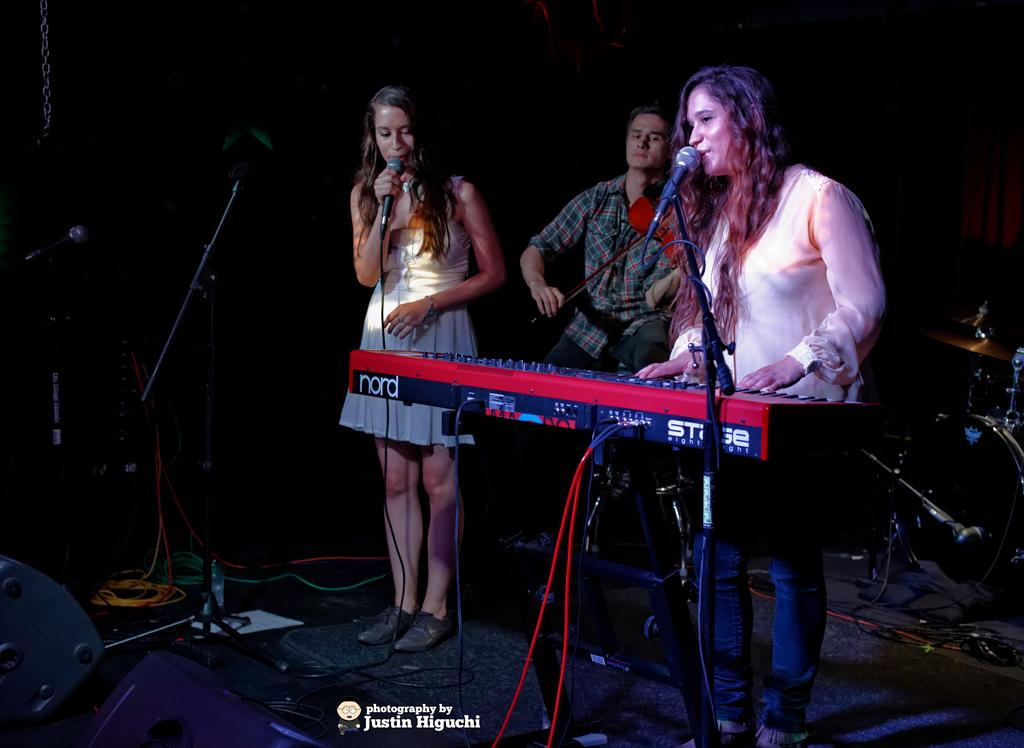How many people are present in the image? There are 3 people in the image. What are two of the people doing in the image? Two people are singing in the image. What is the third person doing in the image? One person is playing the violin, and another is playing the keyboard. What other musical instrument can be seen in the image? There are drums visible in the image. What type of hall is depicted in the image? There is no hall present in the image; it features people playing musical instruments. Can you see a ghost playing the drums in the image? No, there is no ghost present in the image. 